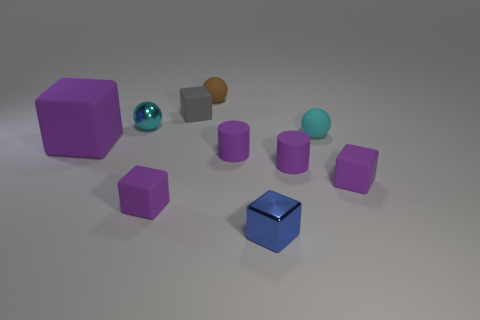Can you tell me a story about these objects? Certainly! In a world of geometric forms, these objects could be characters in a quiet valley of shapes. The purple cubes are siblings, with the largest being the protector of the group. The teal sphere is their shiny friend, full of wisdom and stories. The small gray cube is a traveler from afar, and the warm brown sphere is an old sage, watching over the valley. The small, blue-tinted cube is a rare gem, recently discovered, which they all admire for its unique finish and reflective surface. Together, they learn about the world through their different perspectives, sharing adventures and tales under the gentle glow of the artificial sky. 